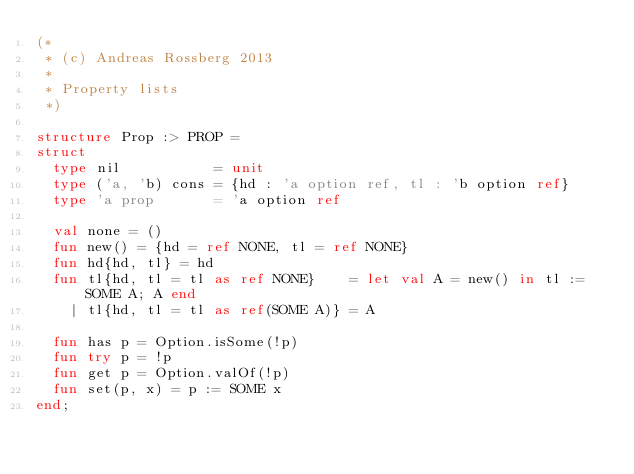Convert code to text. <code><loc_0><loc_0><loc_500><loc_500><_SML_>(*
 * (c) Andreas Rossberg 2013
 *
 * Property lists
 *)

structure Prop :> PROP =
struct
  type nil           = unit
  type ('a, 'b) cons = {hd : 'a option ref, tl : 'b option ref}
  type 'a prop       = 'a option ref

  val none = ()
  fun new() = {hd = ref NONE, tl = ref NONE}
  fun hd{hd, tl} = hd
  fun tl{hd, tl = tl as ref NONE}    = let val A = new() in tl := SOME A; A end
    | tl{hd, tl = tl as ref(SOME A)} = A

  fun has p = Option.isSome(!p)
  fun try p = !p
  fun get p = Option.valOf(!p)
  fun set(p, x) = p := SOME x
end;
</code> 